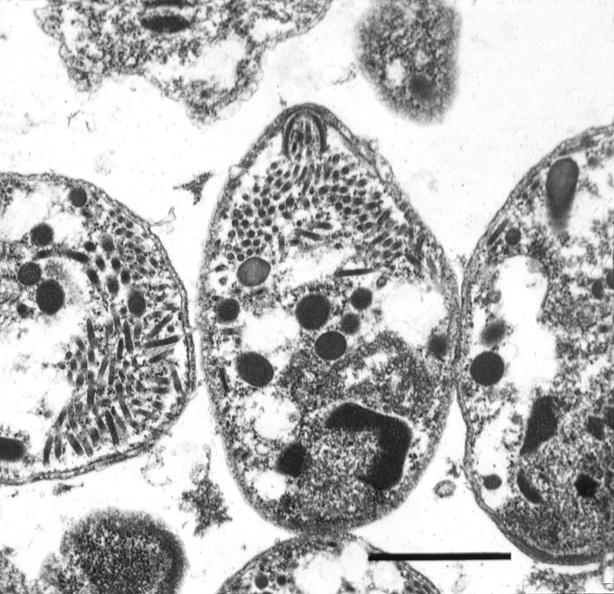what is present?
Answer the question using a single word or phrase. Nervous 